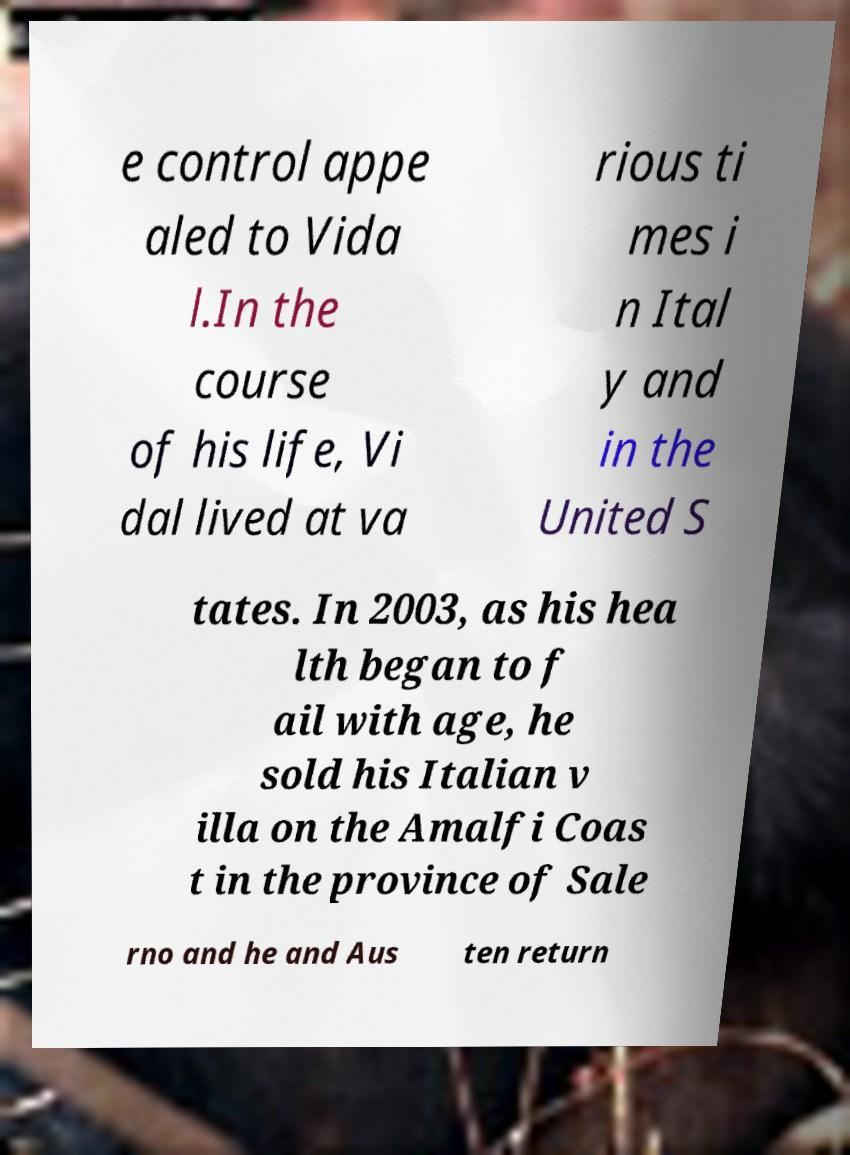For documentation purposes, I need the text within this image transcribed. Could you provide that? e control appe aled to Vida l.In the course of his life, Vi dal lived at va rious ti mes i n Ital y and in the United S tates. In 2003, as his hea lth began to f ail with age, he sold his Italian v illa on the Amalfi Coas t in the province of Sale rno and he and Aus ten return 